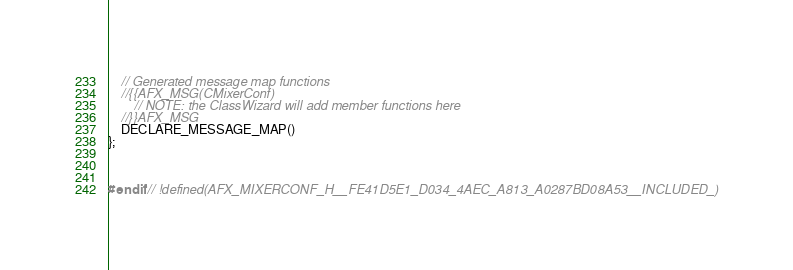<code> <loc_0><loc_0><loc_500><loc_500><_C_>	// Generated message map functions
	//{{AFX_MSG(CMixerConf)
		// NOTE: the ClassWizard will add member functions here
	//}}AFX_MSG
	DECLARE_MESSAGE_MAP()
};



#endif // !defined(AFX_MIXERCONF_H__FE41D5E1_D034_4AEC_A813_A0287BD08A53__INCLUDED_)
</code> 